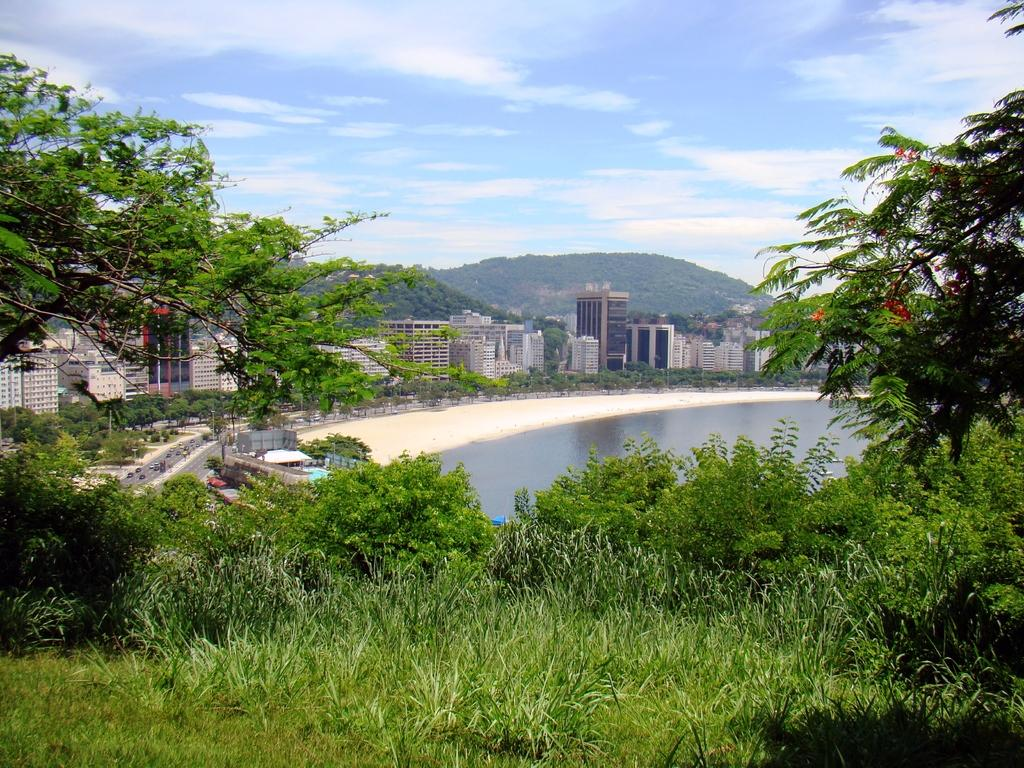What type of vegetation can be seen in the image? There is grass and trees visible in the image. What else can be seen in the image besides vegetation? There are vehicles, water, buildings, and hills visible in the image. What is visible in the background of the image? In the background of the image, there are buildings, hills, water, and clouds. What type of scent can be detected from the cactus in the image? There is no cactus present in the image, so it is not possible to detect any scent from it. 